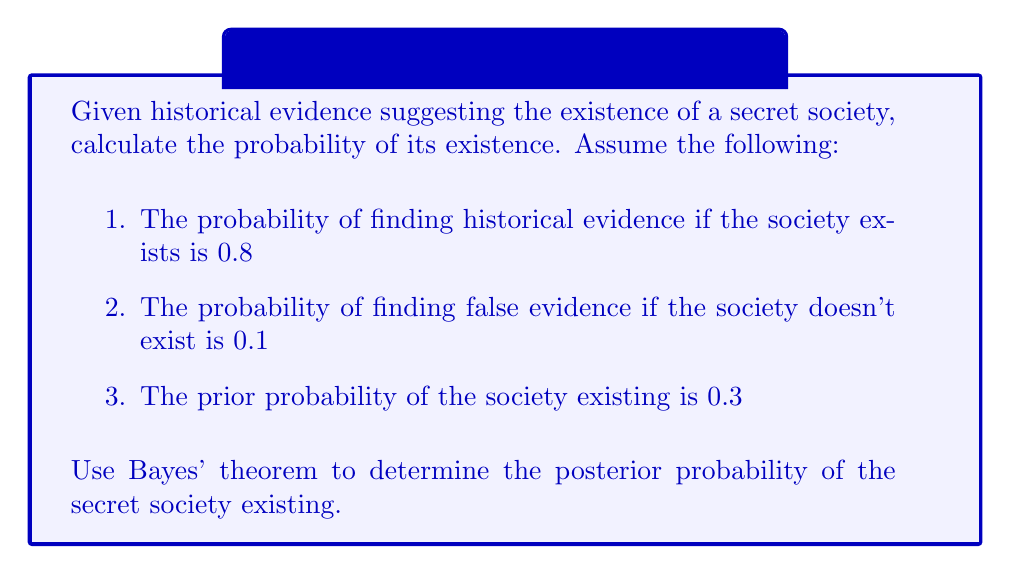Show me your answer to this math problem. Let's approach this step-by-step using Bayes' theorem:

1. Define our events:
   E: Historical evidence is found
   S: Secret society exists

2. Given probabilities:
   P(E|S) = 0.8 (probability of evidence given the society exists)
   P(E|not S) = 0.1 (probability of false evidence)
   P(S) = 0.3 (prior probability of society existing)

3. Bayes' theorem states:

   $$P(S|E) = \frac{P(E|S) \cdot P(S)}{P(E)}$$

4. We need to calculate P(E):
   $$P(E) = P(E|S) \cdot P(S) + P(E|not S) \cdot P(not S)$$
   $$P(E) = 0.8 \cdot 0.3 + 0.1 \cdot 0.7 = 0.31$$

5. Now we can apply Bayes' theorem:

   $$P(S|E) = \frac{0.8 \cdot 0.3}{0.31} \approx 0.7742$$

6. Convert to a percentage:
   0.7742 * 100 ≈ 77.42%

Therefore, given the historical evidence, the probability of the secret society existing is approximately 77.42%.
Answer: 77.42% 